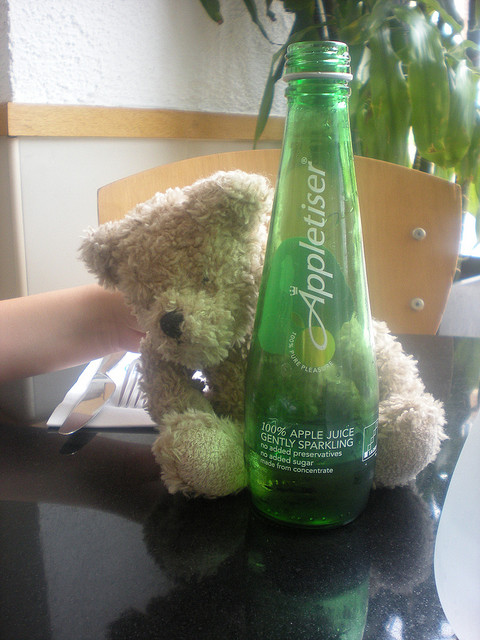Please transcribe the text in this image. Appletiser APPLE JUICE SPARKLING GENTLY added concentrate sugar 100% proservations 